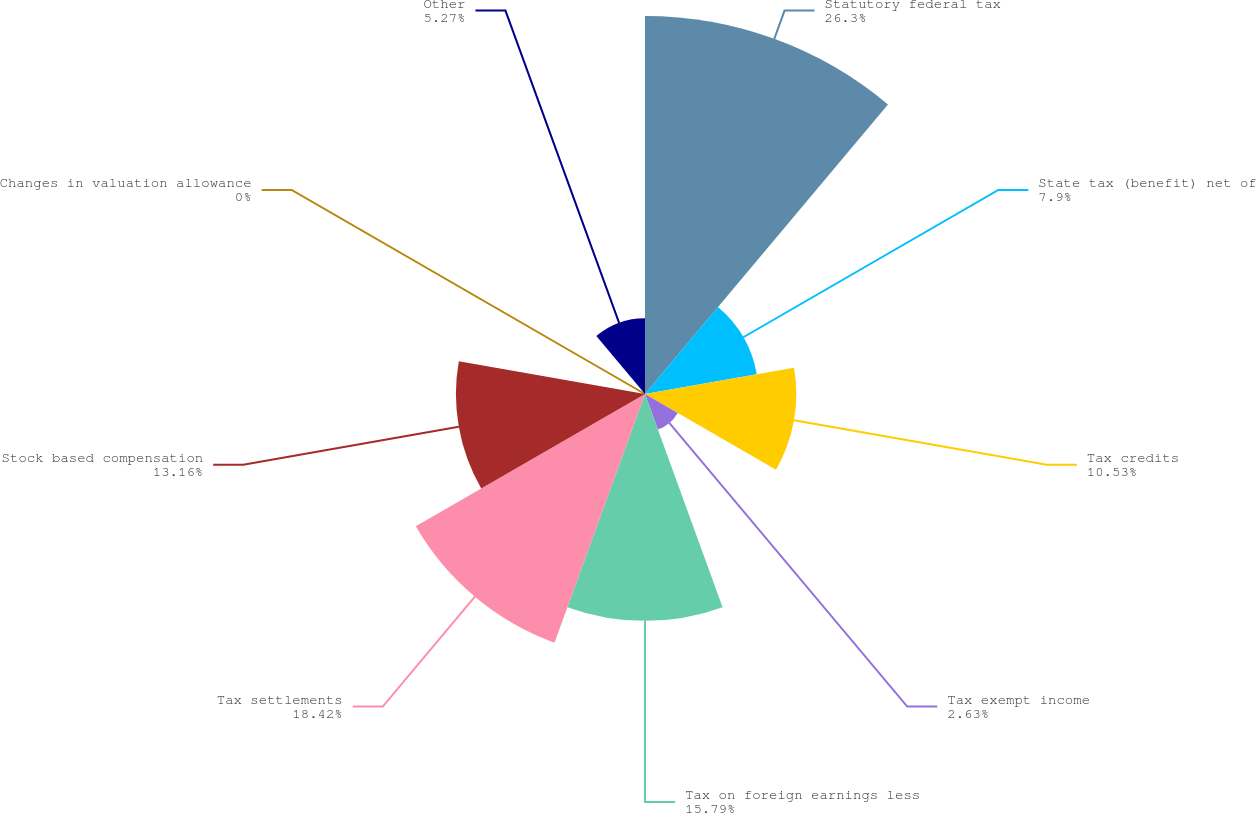Convert chart to OTSL. <chart><loc_0><loc_0><loc_500><loc_500><pie_chart><fcel>Statutory federal tax<fcel>State tax (benefit) net of<fcel>Tax credits<fcel>Tax exempt income<fcel>Tax on foreign earnings less<fcel>Tax settlements<fcel>Stock based compensation<fcel>Changes in valuation allowance<fcel>Other<nl><fcel>26.31%<fcel>7.9%<fcel>10.53%<fcel>2.63%<fcel>15.79%<fcel>18.42%<fcel>13.16%<fcel>0.0%<fcel>5.27%<nl></chart> 